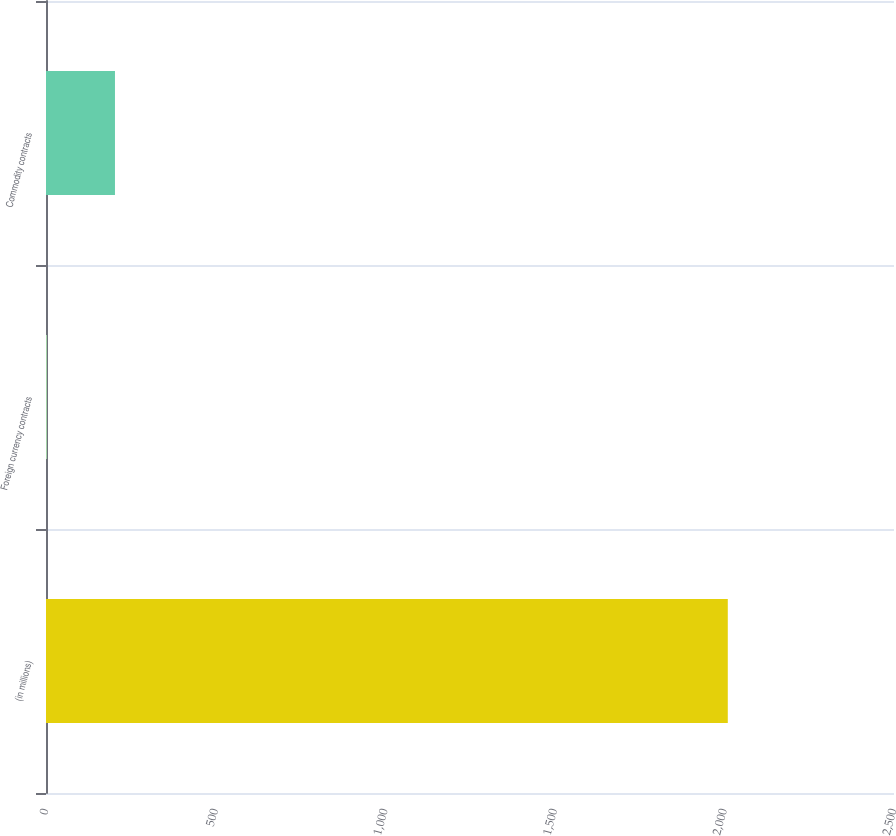<chart> <loc_0><loc_0><loc_500><loc_500><bar_chart><fcel>(in millions)<fcel>Foreign currency contracts<fcel>Commodity contracts<nl><fcel>2010<fcel>2.6<fcel>203.34<nl></chart> 